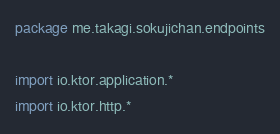<code> <loc_0><loc_0><loc_500><loc_500><_Kotlin_>package me.takagi.sokujichan.endpoints

import io.ktor.application.*
import io.ktor.http.*</code> 